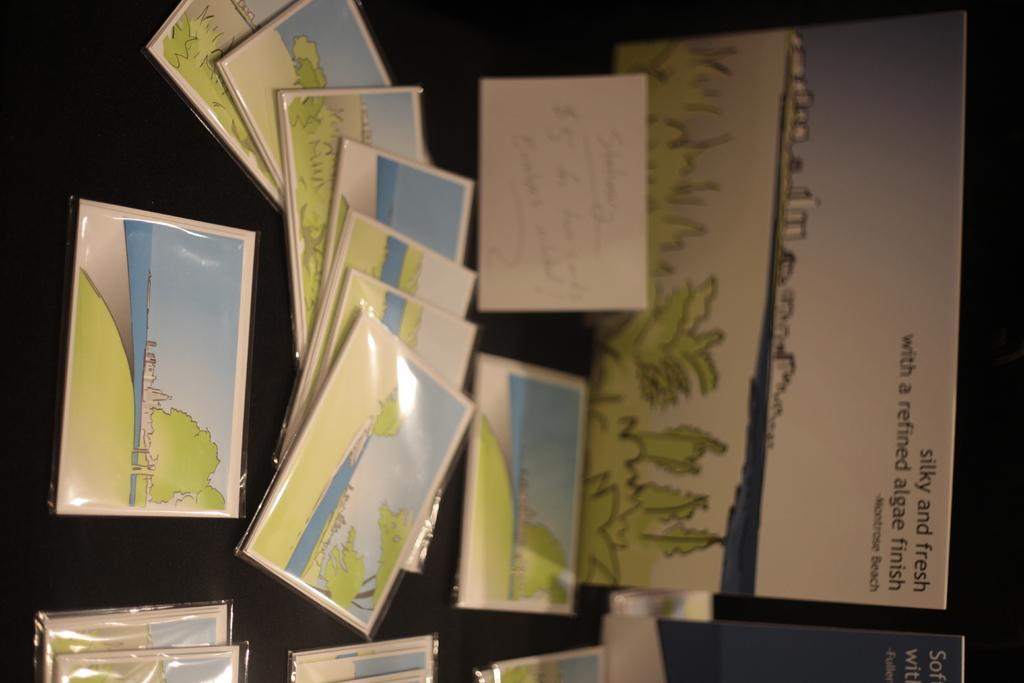<image>
Describe the image concisely. A sign above some cards says "silky and fresh with a refined algae finish." 